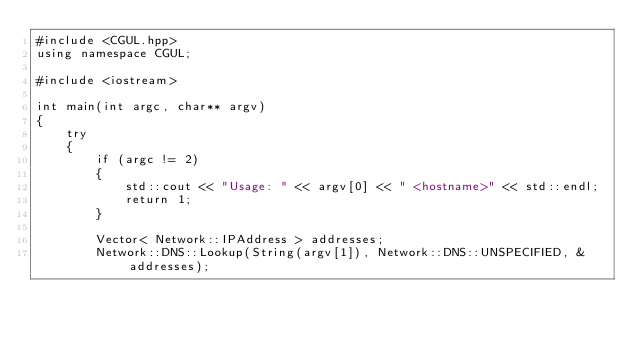<code> <loc_0><loc_0><loc_500><loc_500><_C++_>#include <CGUL.hpp>
using namespace CGUL;

#include <iostream>

int main(int argc, char** argv)
{
    try
    {
        if (argc != 2)
        {
            std::cout << "Usage: " << argv[0] << " <hostname>" << std::endl;
            return 1;
        }

        Vector< Network::IPAddress > addresses;
        Network::DNS::Lookup(String(argv[1]), Network::DNS::UNSPECIFIED, &addresses);
</code> 